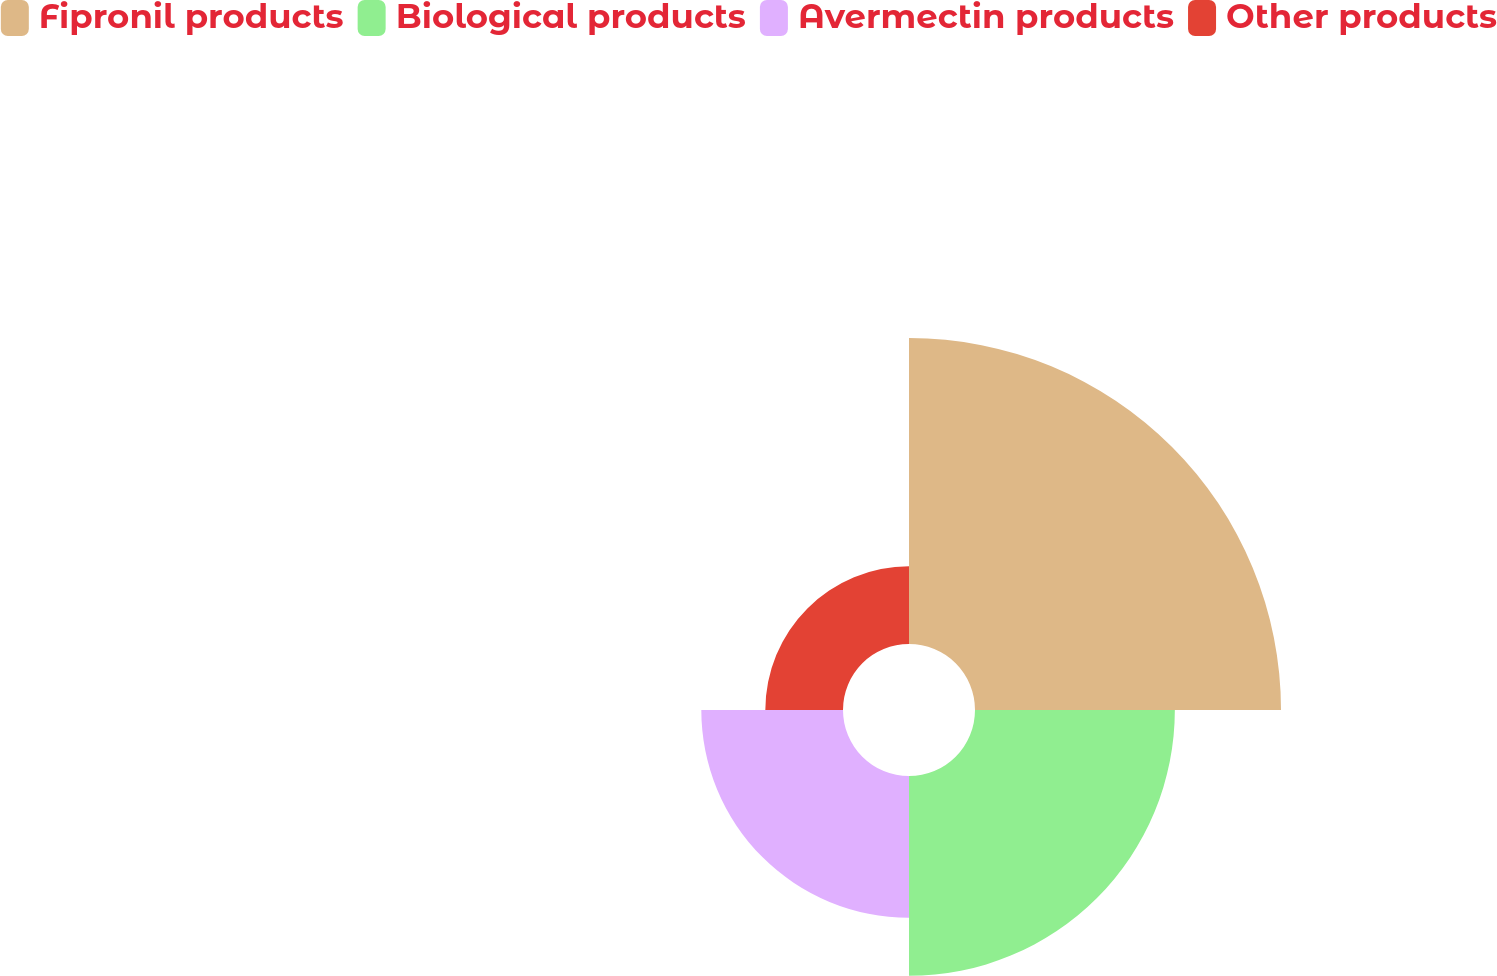Convert chart to OTSL. <chart><loc_0><loc_0><loc_500><loc_500><pie_chart><fcel>Fipronil products<fcel>Biological products<fcel>Avermectin products<fcel>Other products<nl><fcel>42.2%<fcel>27.56%<fcel>19.54%<fcel>10.71%<nl></chart> 